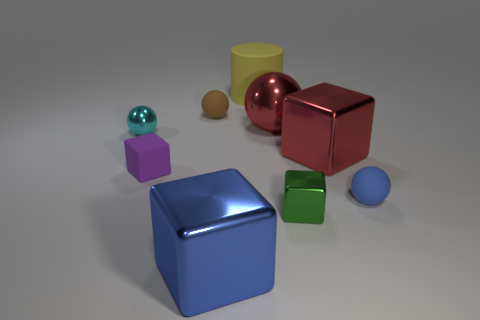Subtract 1 cubes. How many cubes are left? 3 Subtract all green blocks. Subtract all yellow balls. How many blocks are left? 3 Subtract all spheres. How many objects are left? 5 Subtract 0 green balls. How many objects are left? 9 Subtract all large objects. Subtract all purple things. How many objects are left? 4 Add 3 green metallic cubes. How many green metallic cubes are left? 4 Add 1 small cyan cubes. How many small cyan cubes exist? 1 